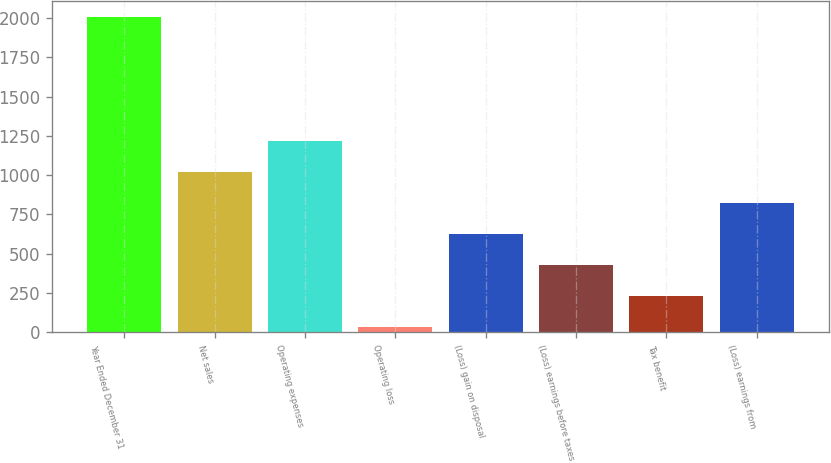Convert chart. <chart><loc_0><loc_0><loc_500><loc_500><bar_chart><fcel>Year Ended December 31<fcel>Net sales<fcel>Operating expenses<fcel>Operating loss<fcel>(Loss) gain on disposal<fcel>(Loss) earnings before taxes<fcel>Tax benefit<fcel>(Loss) earnings from<nl><fcel>2006<fcel>1020<fcel>1217.2<fcel>34<fcel>625.6<fcel>428.4<fcel>231.2<fcel>822.8<nl></chart> 